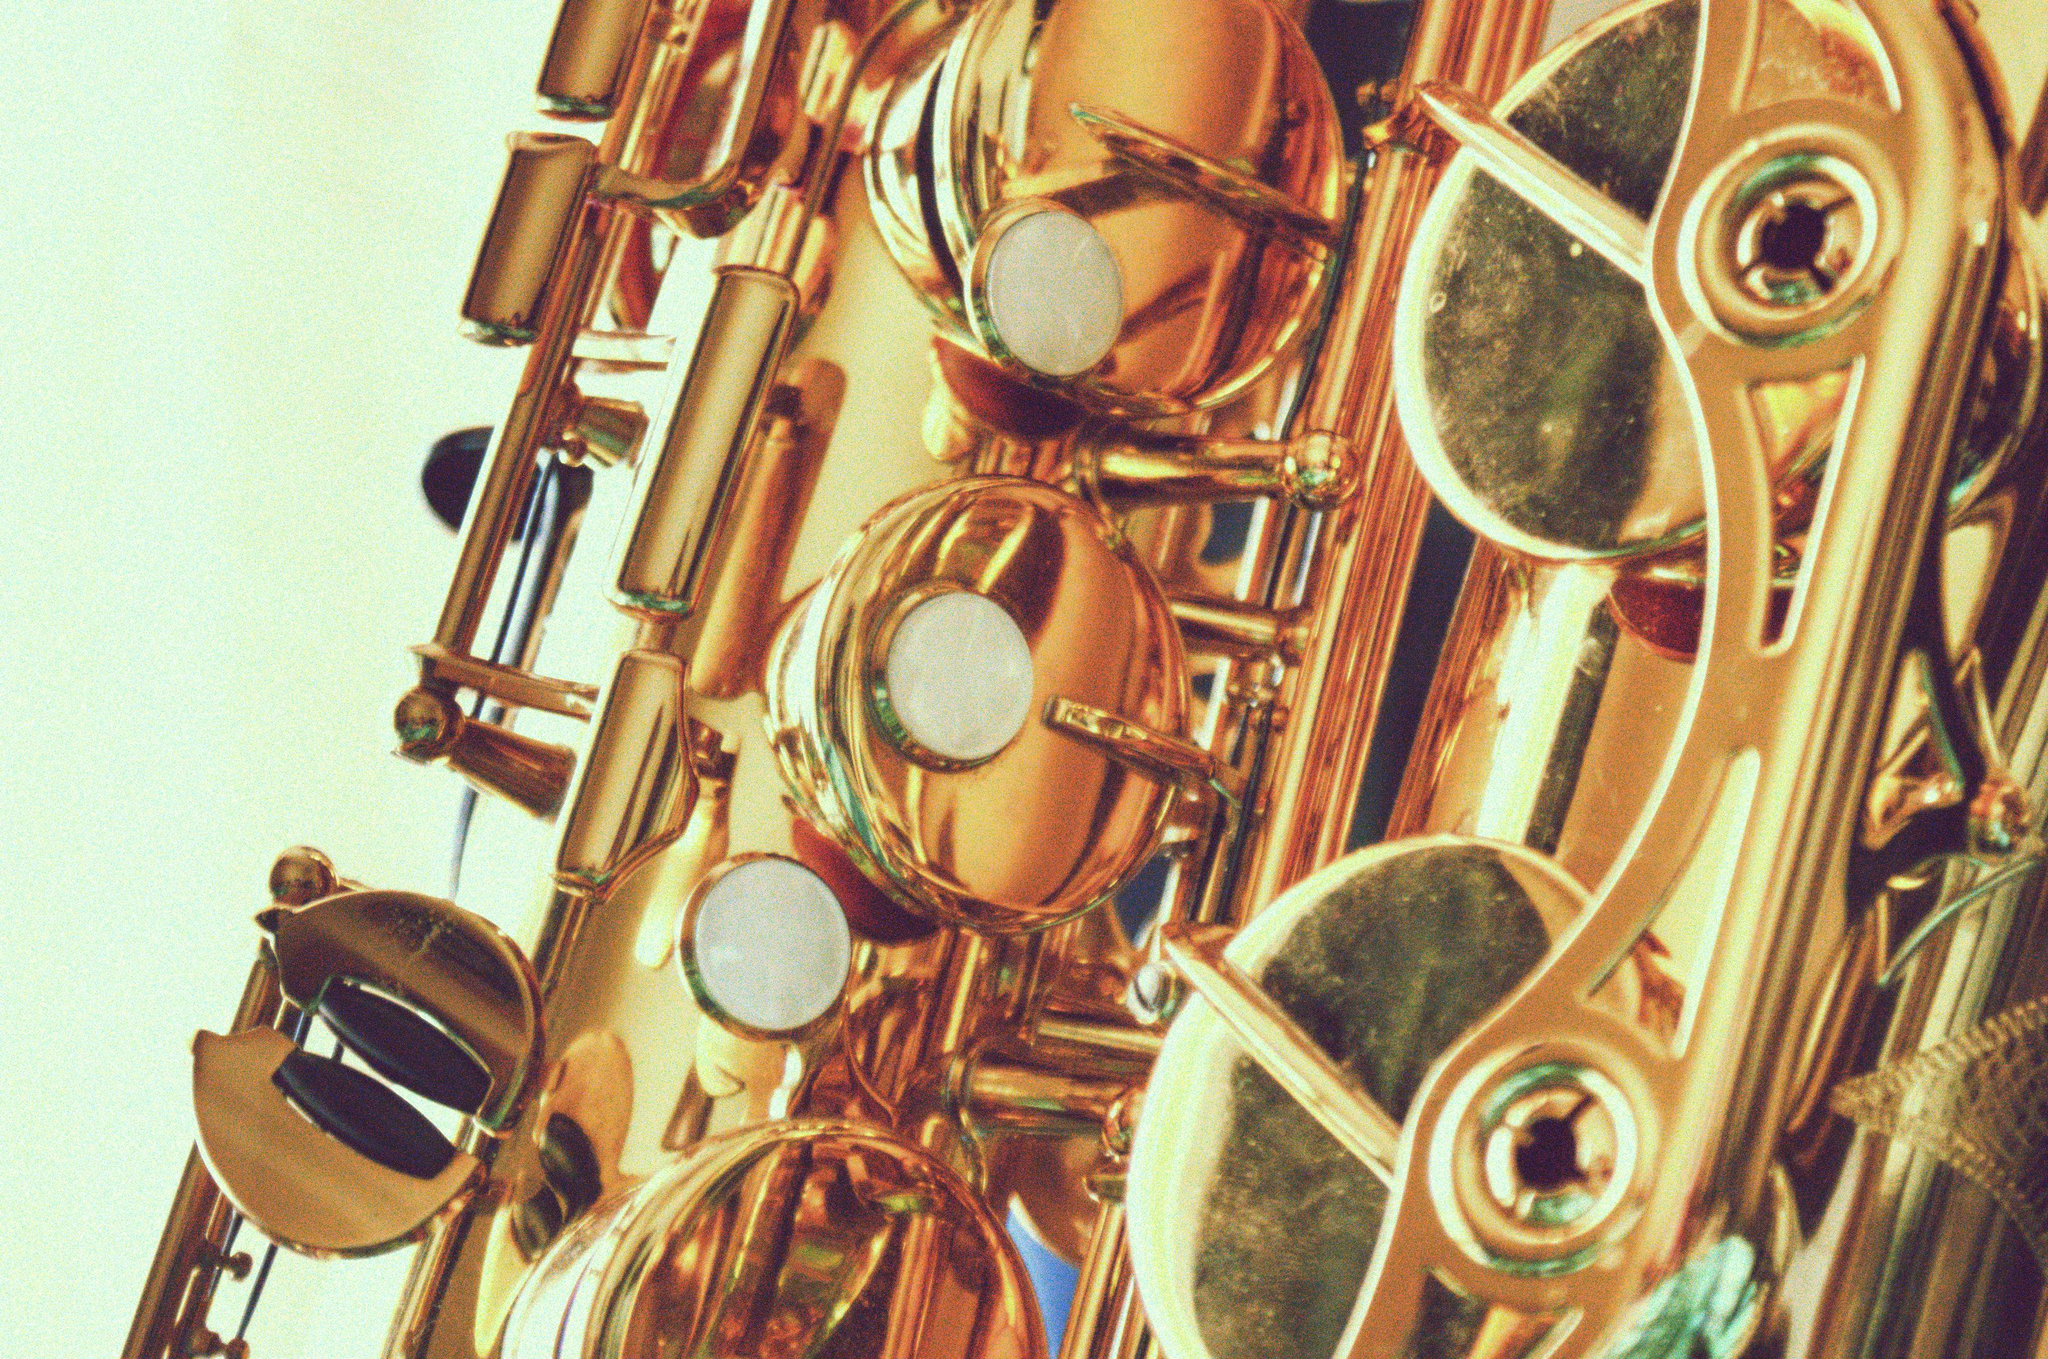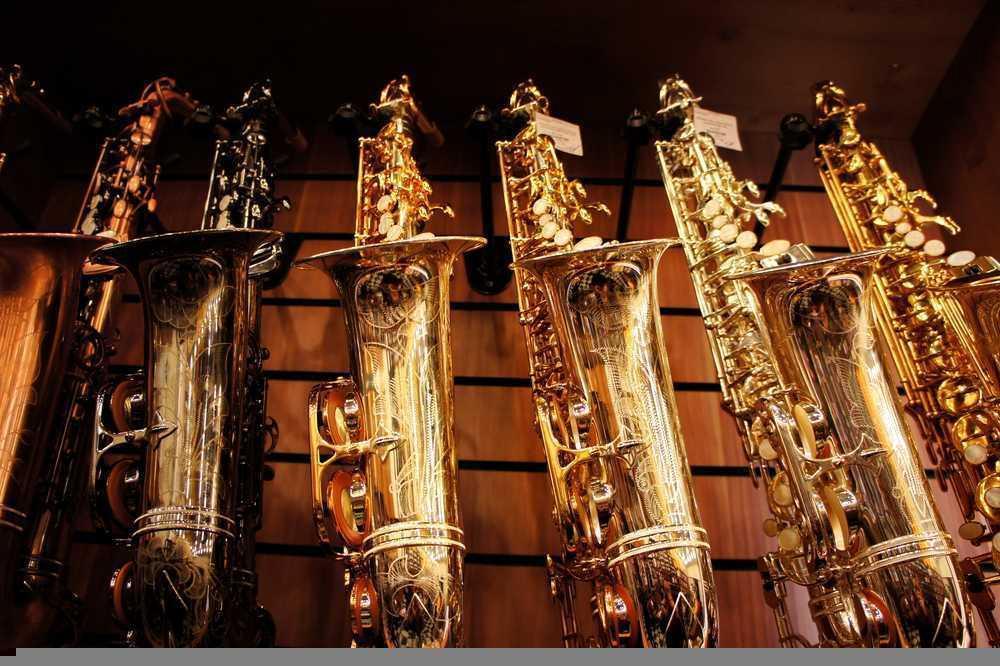The first image is the image on the left, the second image is the image on the right. Examine the images to the left and right. Is the description "At least one of the saxophones is polished." accurate? Answer yes or no. Yes. The first image is the image on the left, the second image is the image on the right. Given the left and right images, does the statement "In at least one image, the close up picture reveals text that has been engraved into the saxophone." hold true? Answer yes or no. No. 